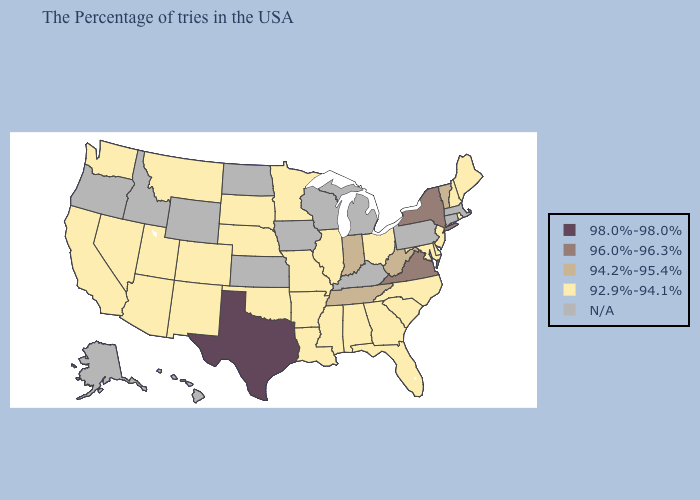What is the highest value in states that border New Hampshire?
Answer briefly. 94.2%-95.4%. What is the value of Kentucky?
Be succinct. N/A. Does Indiana have the lowest value in the MidWest?
Write a very short answer. No. Which states have the highest value in the USA?
Keep it brief. Texas. Name the states that have a value in the range N/A?
Be succinct. Massachusetts, Connecticut, Pennsylvania, Michigan, Kentucky, Wisconsin, Iowa, Kansas, North Dakota, Wyoming, Idaho, Oregon, Alaska, Hawaii. What is the value of Texas?
Write a very short answer. 98.0%-98.0%. Name the states that have a value in the range 94.2%-95.4%?
Short answer required. Vermont, West Virginia, Indiana, Tennessee. Does Texas have the highest value in the USA?
Write a very short answer. Yes. Which states have the lowest value in the West?
Be succinct. Colorado, New Mexico, Utah, Montana, Arizona, Nevada, California, Washington. Does New Hampshire have the highest value in the Northeast?
Keep it brief. No. What is the highest value in the USA?
Concise answer only. 98.0%-98.0%. Name the states that have a value in the range 98.0%-98.0%?
Concise answer only. Texas. What is the highest value in the West ?
Give a very brief answer. 92.9%-94.1%. Name the states that have a value in the range N/A?
Quick response, please. Massachusetts, Connecticut, Pennsylvania, Michigan, Kentucky, Wisconsin, Iowa, Kansas, North Dakota, Wyoming, Idaho, Oregon, Alaska, Hawaii. 